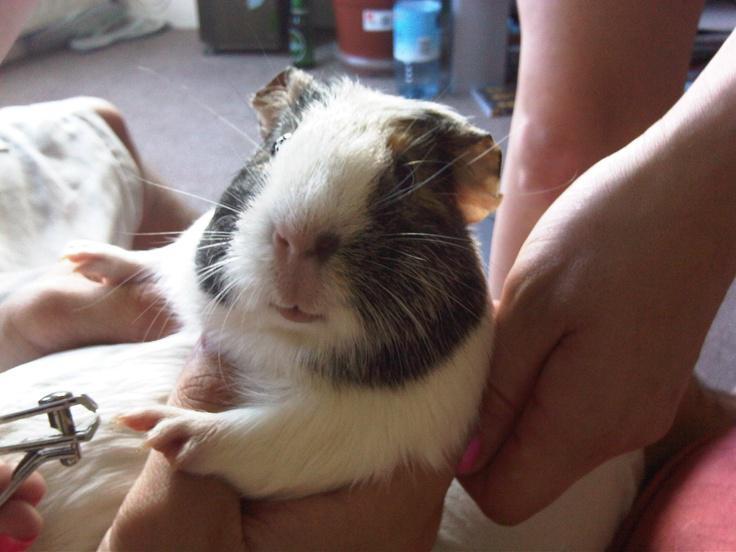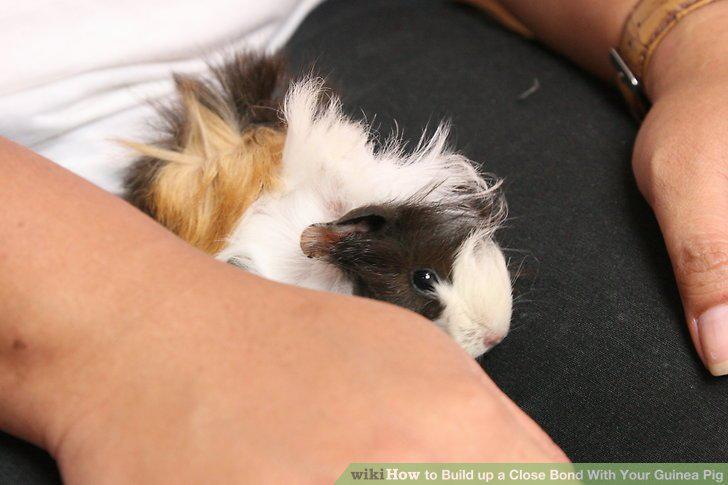The first image is the image on the left, the second image is the image on the right. Evaluate the accuracy of this statement regarding the images: "Each image shows a guinea pigs held in an upturned palm of at least one hand.". Is it true? Answer yes or no. No. The first image is the image on the left, the second image is the image on the right. Examine the images to the left and right. Is the description "There is a guinea pig in the right image looking towards the right." accurate? Answer yes or no. Yes. 